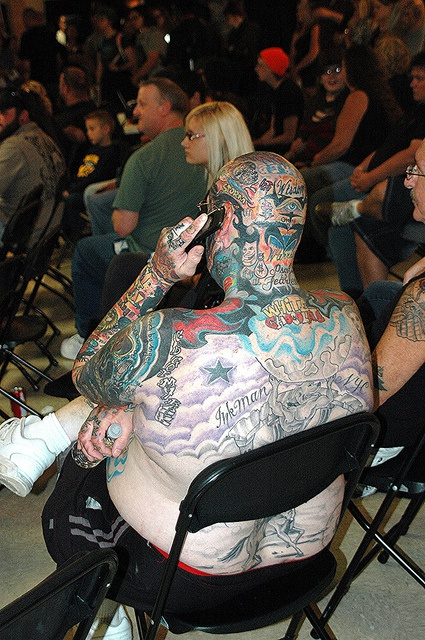Describe the objects in this image and their specific colors. I can see people in black, lightgray, darkgray, and gray tones, chair in black, darkgray, lightgray, and gray tones, people in black, gray, darkgreen, and maroon tones, chair in black, gray, maroon, and darkgray tones, and people in black, maroon, and gray tones in this image. 